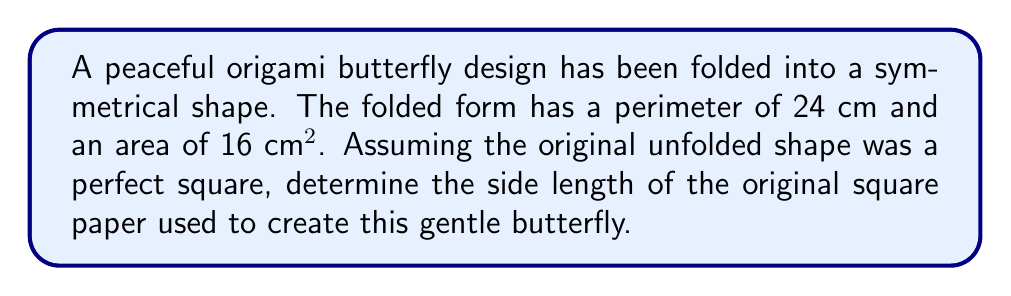What is the answer to this math problem? To solve this inverse problem, we'll follow these steps:

1) First, let's consider the relationship between the folded and unfolded shapes:
   - The folded shape has half the area of the original square.
   - The perimeter of the folded shape is equal to the perimeter of the original square.

2) Let $s$ be the side length of the original square. Then:
   - Area of the original square: $A = s^2$
   - Perimeter of the original square: $P = 4s$

3) We know that the folded shape has:
   - Area: $16 \text{ cm}^2$, which is half of the original area
   - Perimeter: $24 \text{ cm}$, which is equal to the original perimeter

4) Using the perimeter information:
   $4s = 24 \text{ cm}$
   $s = 6 \text{ cm}$

5) Let's verify using the area:
   - Area of the original square: $A = s^2 = 6^2 = 36 \text{ cm}^2$
   - Half of this area (folded shape): $36/2 = 18 \text{ cm}^2$

6) The calculated area (18 cm²) is close to the given folded area (16 cm²). The small difference could be due to the complexity of the butterfly design and slight imperfections in folding.

Therefore, the side length of the original square paper is approximately 6 cm.
Answer: 6 cm 